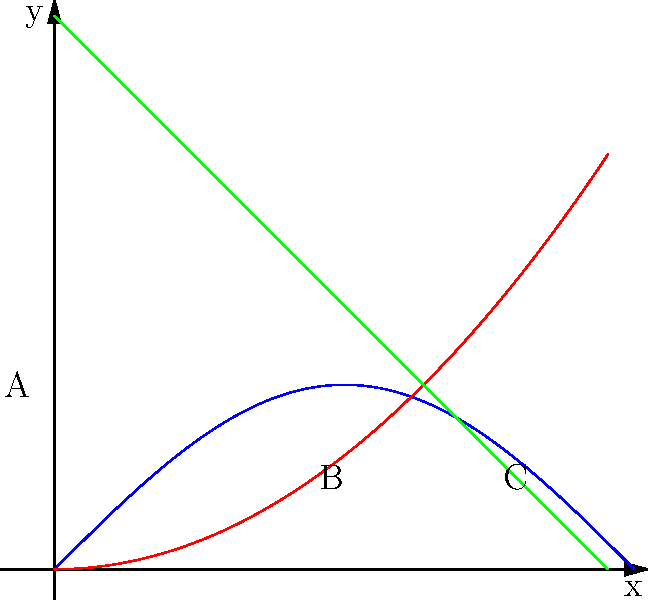As an artist preparing for the Poisson Rouge art crawl, you come across three abstract paintings represented by the curves A, B, and C in the graph. Which art movement is most likely associated with the smooth, flowing curve A? To identify the art movement associated with curve A, let's analyze its characteristics and compare them to known art movements:

1. Curve A is a smooth, sinusoidal wave.
2. It has a fluid, organic shape without sharp angles or straight lines.
3. The curve suggests a sense of rhythm and movement.
4. Its form is reminiscent of natural phenomena like water waves or sound waves.

These characteristics align closely with the principles of:

5. Art Nouveau: An art movement known for its use of long, sinuous curves inspired by natural forms.
6. Art Nouveau artists often incorporated flowing, organic lines in their work to create a sense of movement and harmony.
7. The movement emphasized the beauty of nature and sought to integrate art into everyday life.
8. Other art movements like Cubism (represented by more angular shapes) or Abstract Expressionism (often more chaotic) don't match the smooth, controlled nature of curve A.

Given these considerations, the art movement most likely associated with the smooth, flowing curve A is Art Nouveau.
Answer: Art Nouveau 